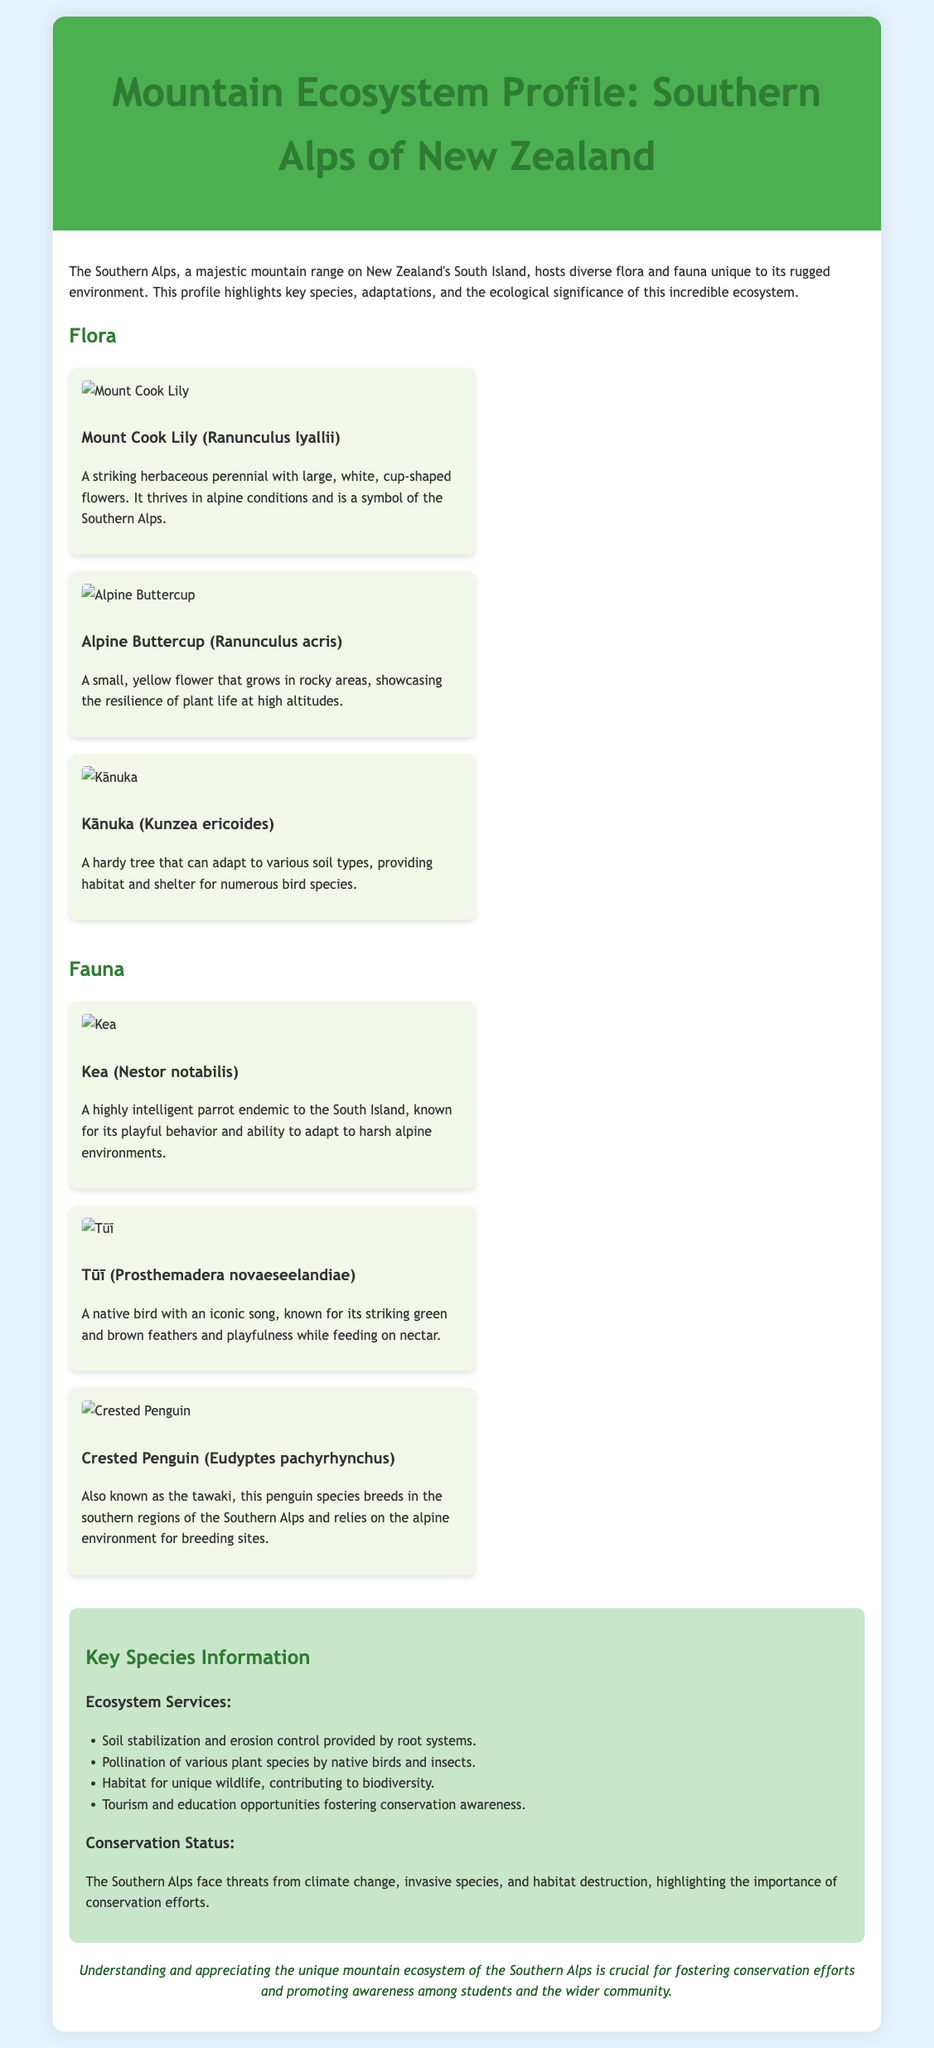What is the title of the document? The title is explicitly stated in the header section of the document.
Answer: Mountain Ecosystem Profile: Southern Alps of New Zealand What type of plant is the Mount Cook Lily? The document classifies the Mount Cook Lily under flora, as it describes key species of plants in the Southern Alps.
Answer: Herbaceous perennial Which species is known for its iconic song? This information is provided in the fauna section, detailing a specific characteristic of the Tūī.
Answer: Tūī What ecological role do native birds and insects play? The document outlines ecosystem services provided by species within the Southern Alps.
Answer: Pollination What is one threat to the Southern Alps mentioned? The threats to the ecosystem are discussed in the conservation section of the note.
Answer: Climate change How many faunal species are listed in the document? The question relates to the count of species detailed specifically, as shown in the fauna section.
Answer: Three Which species is referred to as the tawaki? The document provides an alias for the Crested Penguin under the fauna description.
Answer: Crested Penguin What is one benefit of understanding the Southern Alps ecosystem? The conclusion explains the importance of awareness regarding the mountain ecosystem for conservation.
Answer: Fostering conservation efforts 